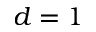Convert formula to latex. <formula><loc_0><loc_0><loc_500><loc_500>d = 1</formula> 